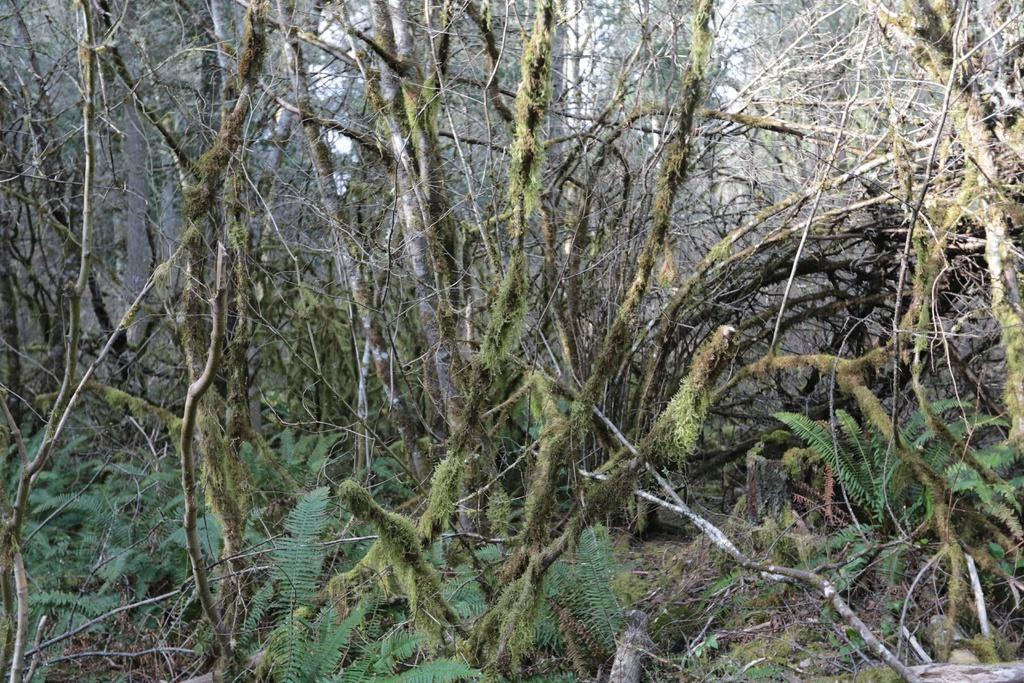What type of vegetation can be seen in the image? There are trees and plants in the image. Can you describe the specific types of plants in the image? Unfortunately, the provided facts do not specify the types of plants in the image. What is the primary color of the trees in the image? The facts do not mention the color of the trees in the image. How many eyes can be seen on the apple in the image? There is no apple present in the image, and therefore no eyes can be seen on it. 